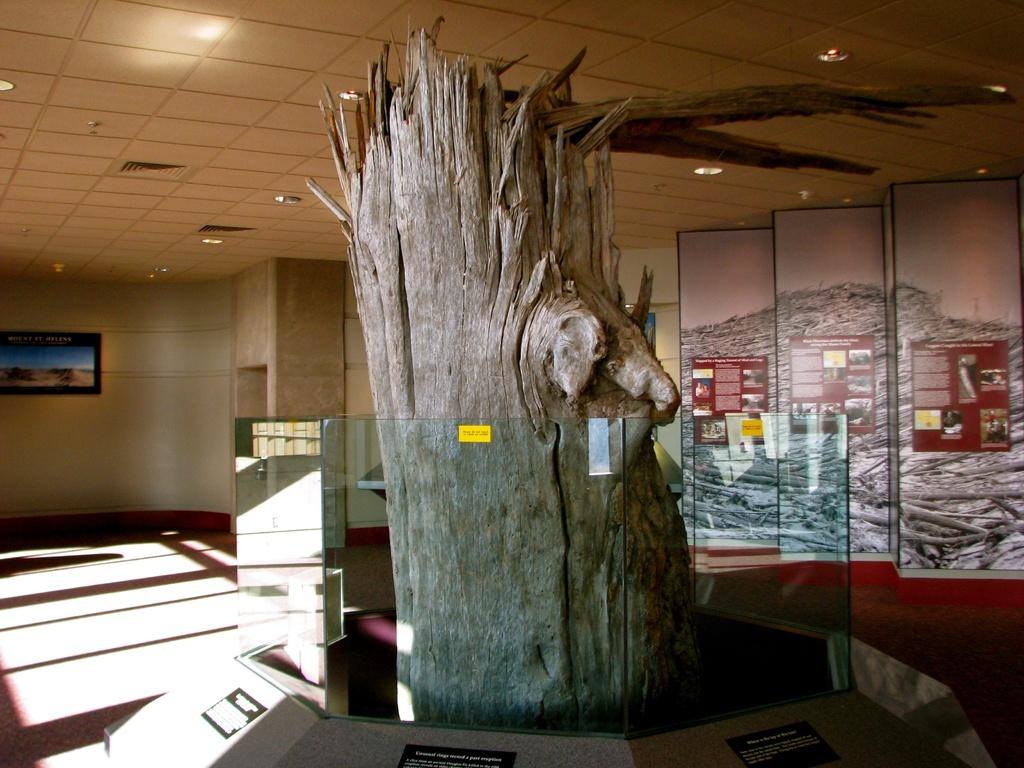What is inside the glass in the image? There is a tree trunk inside the glass in the image. What can be seen attached to the wall in the image? There are boards attached to the wall in the image. What is visible at the top of the image? The ceiling with lights is visible at the top of the image. What type of development is taking place in the image? There is no development project or activity visible in the image; it features a tree trunk inside a glass, boards attached to a wall, and a ceiling with lights. What kind of meal is being prepared in the image? There is no meal preparation or food visible in the image. 